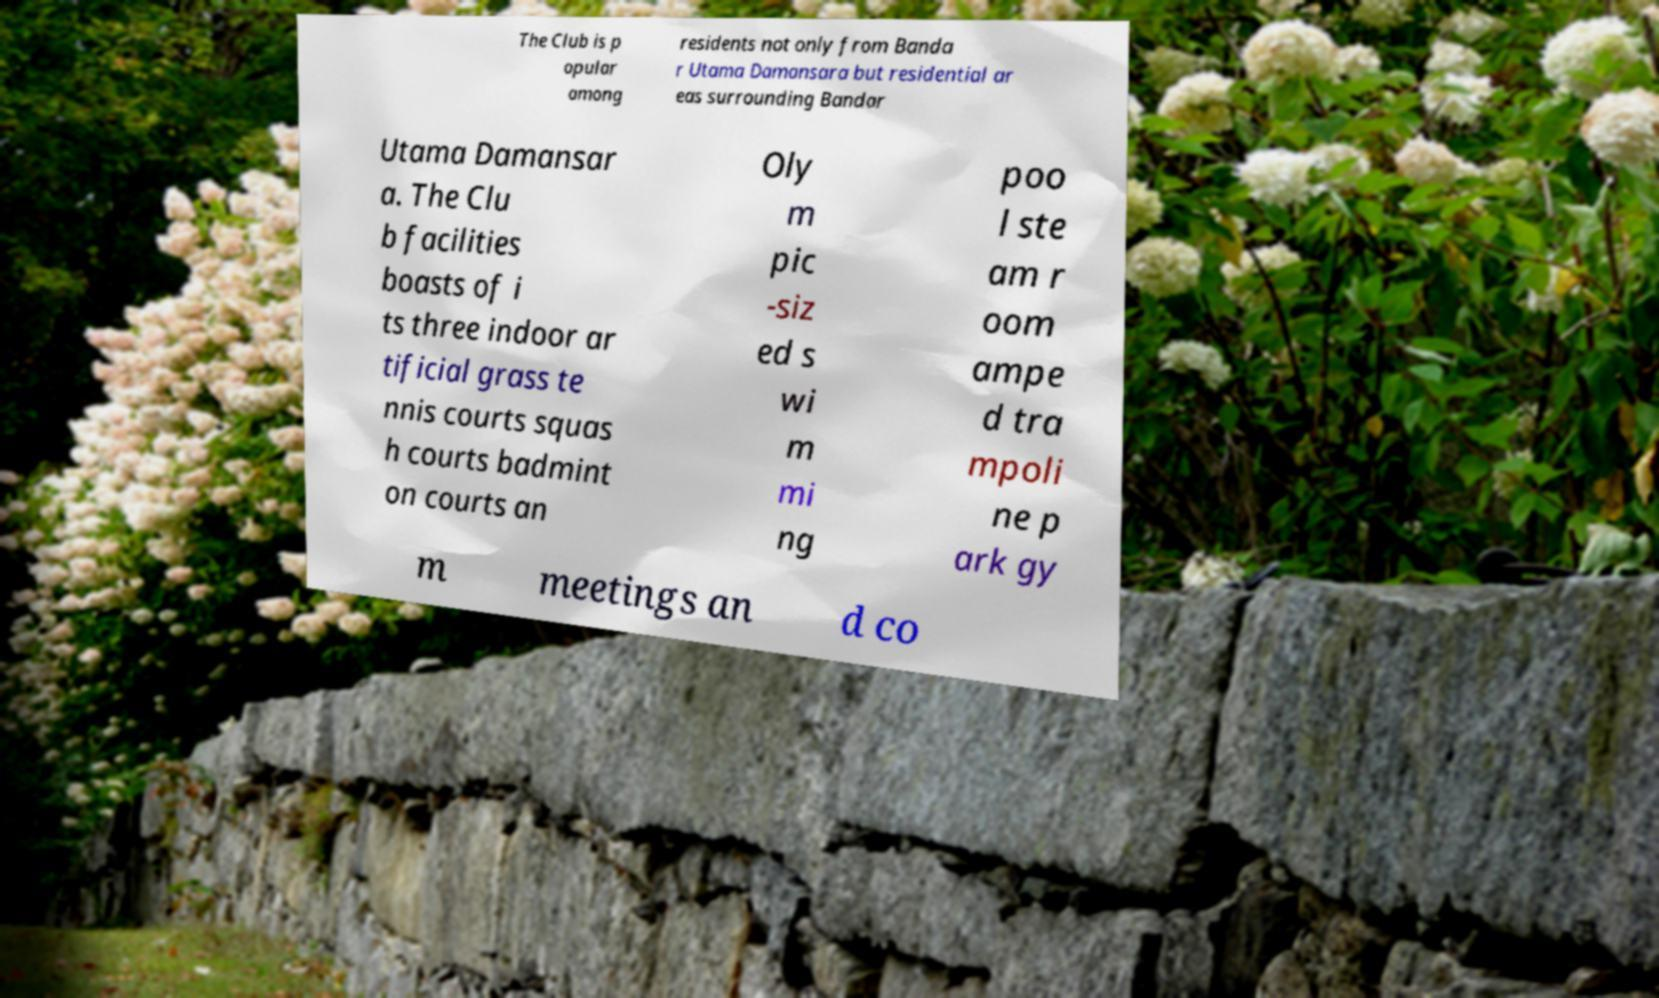For documentation purposes, I need the text within this image transcribed. Could you provide that? The Club is p opular among residents not only from Banda r Utama Damansara but residential ar eas surrounding Bandar Utama Damansar a. The Clu b facilities boasts of i ts three indoor ar tificial grass te nnis courts squas h courts badmint on courts an Oly m pic -siz ed s wi m mi ng poo l ste am r oom ampe d tra mpoli ne p ark gy m meetings an d co 